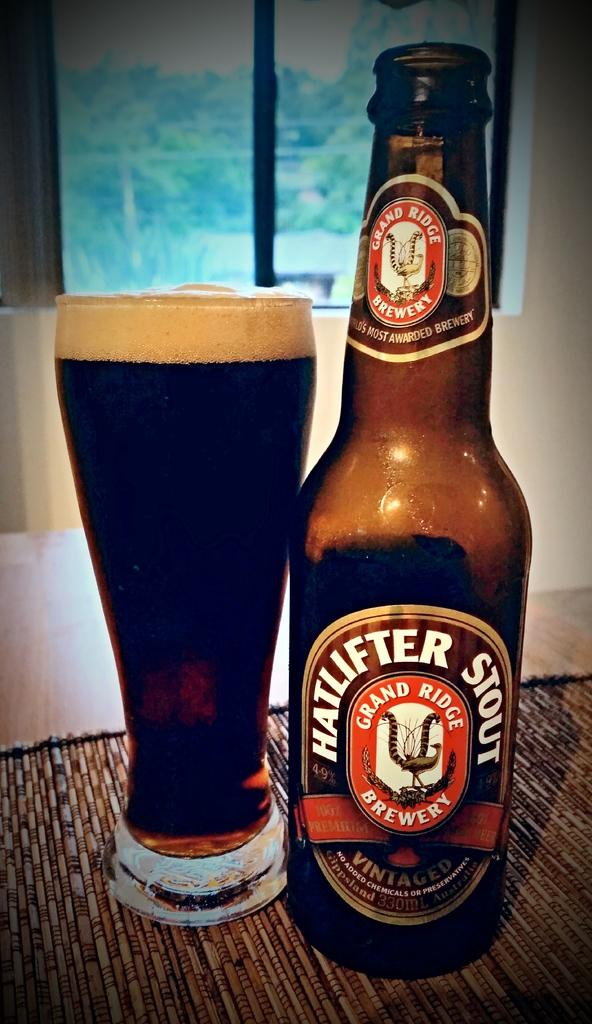<image>
Present a compact description of the photo's key features. A glass of Hatlifter Stout next to the empty bottle. 